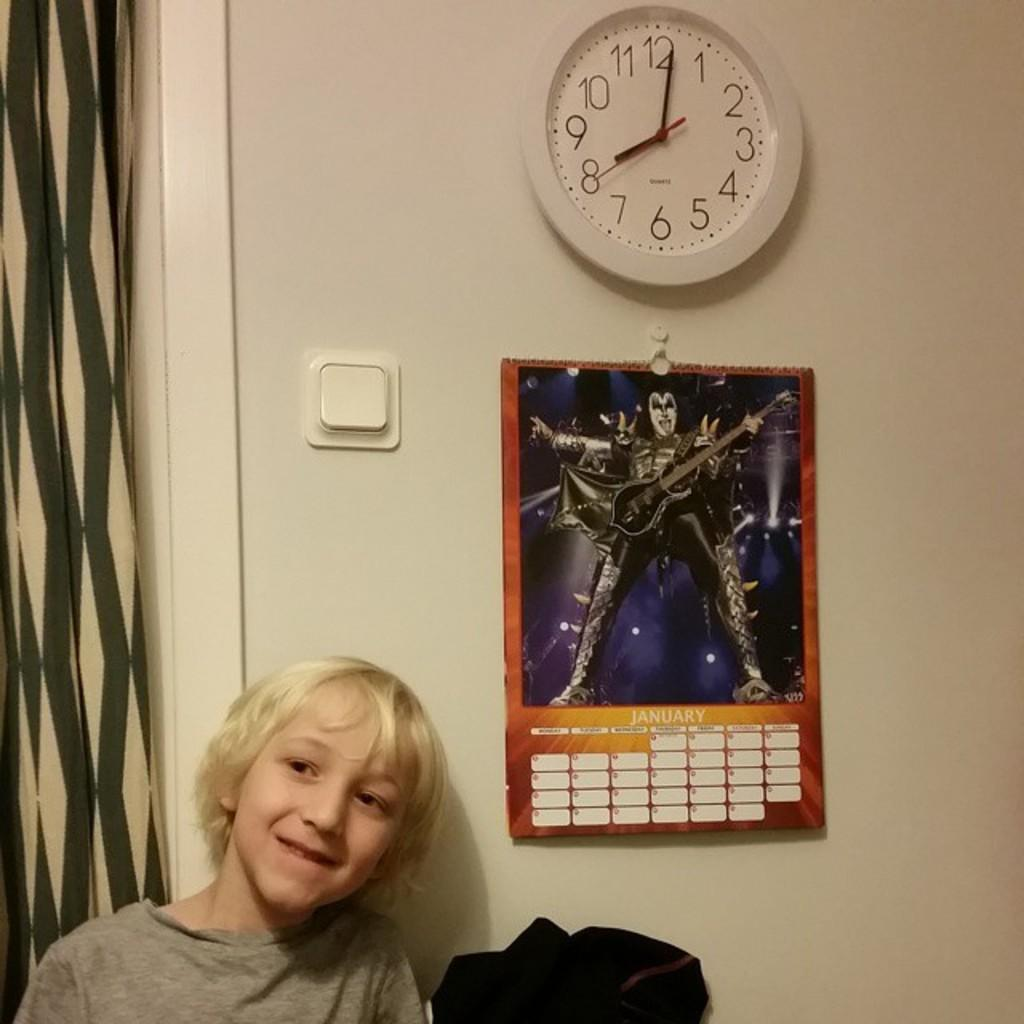<image>
Provide a brief description of the given image. A smiling child is next to a January calendar that has a white clock above it that shows a time of 8:01. 